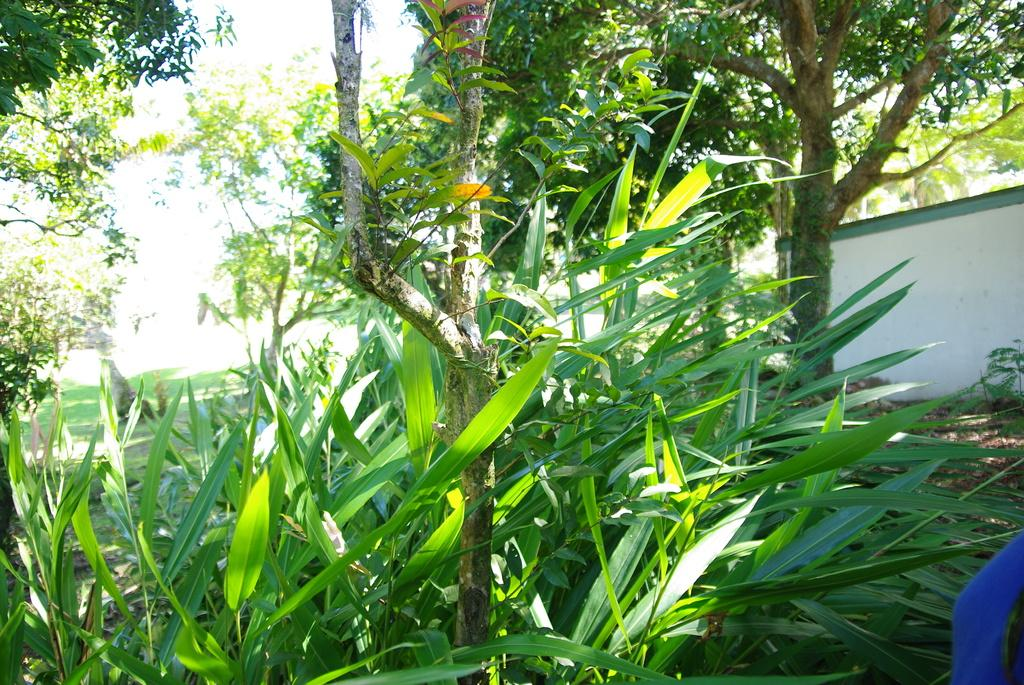What is covering the ground in the image? There are shredded leaves on the ground in the image. What type of vegetation can be seen in the image? There are plants and trees in the image. What is visible in the background of the image? The sky is visible in the image. Are there any ghosts visible in the image? No, there are no ghosts present in the image. What type of quiver can be seen in the image? There is no quiver present in the image. 